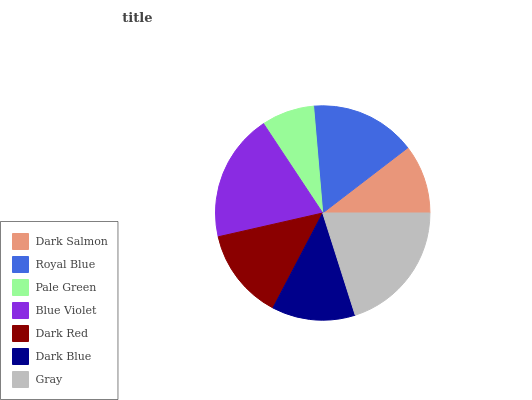Is Pale Green the minimum?
Answer yes or no. Yes. Is Gray the maximum?
Answer yes or no. Yes. Is Royal Blue the minimum?
Answer yes or no. No. Is Royal Blue the maximum?
Answer yes or no. No. Is Royal Blue greater than Dark Salmon?
Answer yes or no. Yes. Is Dark Salmon less than Royal Blue?
Answer yes or no. Yes. Is Dark Salmon greater than Royal Blue?
Answer yes or no. No. Is Royal Blue less than Dark Salmon?
Answer yes or no. No. Is Dark Red the high median?
Answer yes or no. Yes. Is Dark Red the low median?
Answer yes or no. Yes. Is Dark Salmon the high median?
Answer yes or no. No. Is Dark Blue the low median?
Answer yes or no. No. 